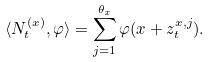Convert formula to latex. <formula><loc_0><loc_0><loc_500><loc_500>\langle N ^ { ( x ) } _ { t } , \varphi \rangle = \sum _ { j = 1 } ^ { \theta _ { x } } \varphi ( x + z ^ { x , j } _ { t } ) .</formula> 